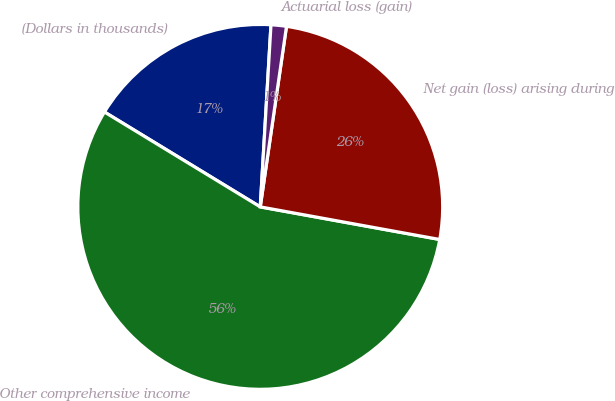Convert chart. <chart><loc_0><loc_0><loc_500><loc_500><pie_chart><fcel>(Dollars in thousands)<fcel>Other comprehensive income<fcel>Net gain (loss) arising during<fcel>Actuarial loss (gain)<nl><fcel>17.23%<fcel>55.84%<fcel>25.56%<fcel>1.36%<nl></chart> 